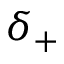Convert formula to latex. <formula><loc_0><loc_0><loc_500><loc_500>\delta _ { + }</formula> 